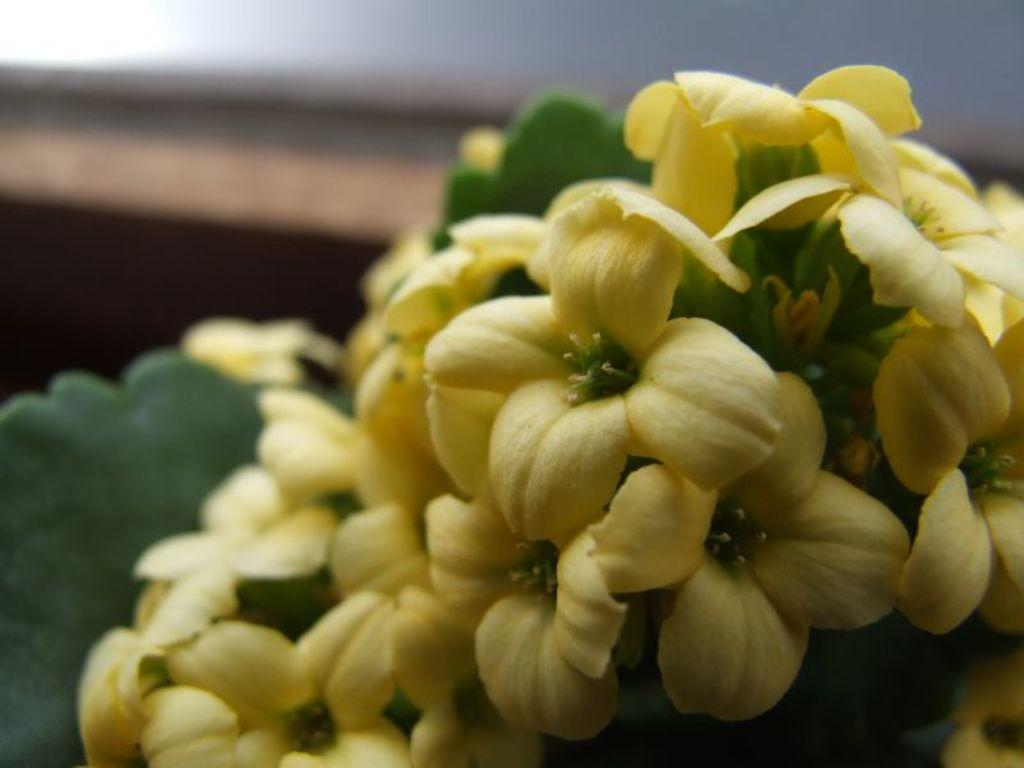What type of plant is visible in the image? There is a plant with a bunch of flowers in the image. Can you describe the flowers on the plant? The flowers are grouped together in a bunch on the plant. What color is the silver notebook on the plant in the image? There is no silver notebook present in the image; it only features a plant with a bunch of flowers. 